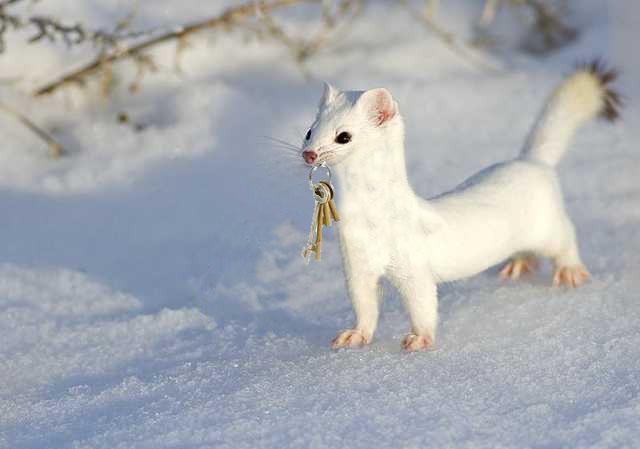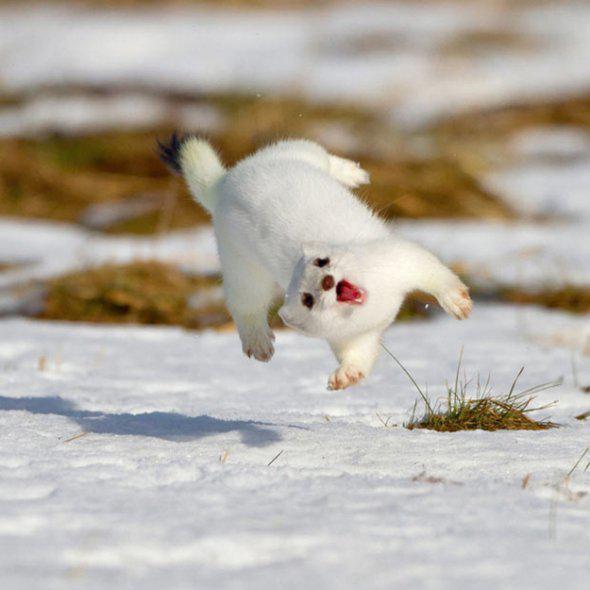The first image is the image on the left, the second image is the image on the right. Assess this claim about the two images: "The right image has a ferret peeking out of the snow.". Correct or not? Answer yes or no. No. 